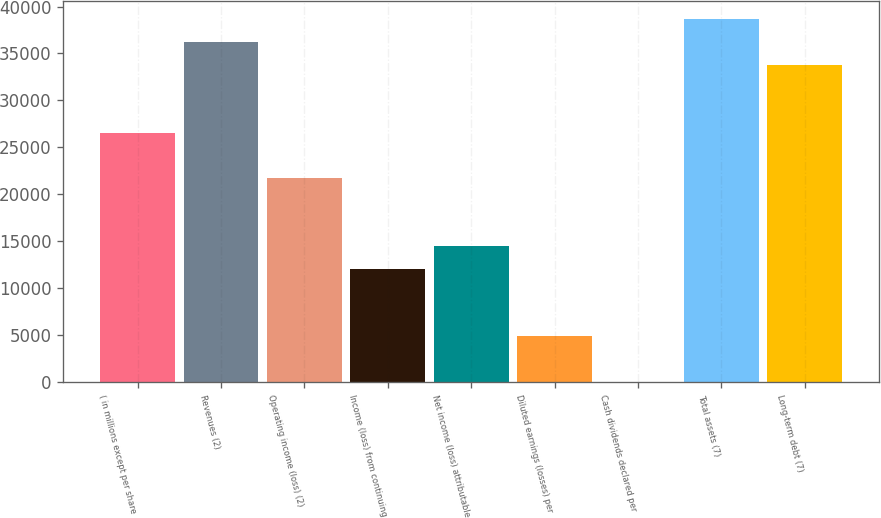Convert chart. <chart><loc_0><loc_0><loc_500><loc_500><bar_chart><fcel>( in millions except per share<fcel>Revenues (2)<fcel>Operating income (loss) (2)<fcel>Income (loss) from continuing<fcel>Net income (loss) attributable<fcel>Diluted earnings (losses) per<fcel>Cash dividends declared per<fcel>Total assets (7)<fcel>Long-term debt (7)<nl><fcel>26553.9<fcel>36209.4<fcel>21726.1<fcel>12070.6<fcel>14484.5<fcel>4828.91<fcel>1.15<fcel>38623.3<fcel>33795.5<nl></chart> 